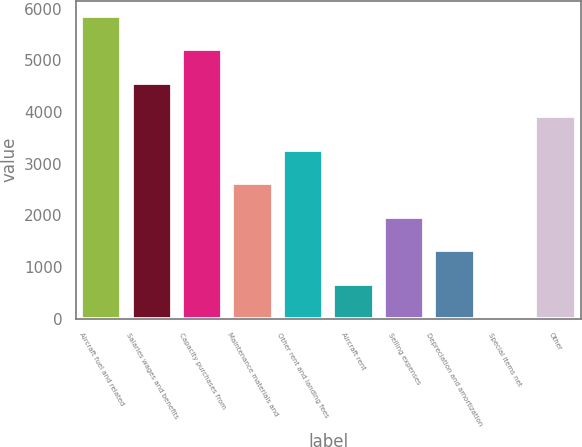Convert chart. <chart><loc_0><loc_0><loc_500><loc_500><bar_chart><fcel>Aircraft fuel and related<fcel>Salaries wages and benefits<fcel>Capacity purchases from<fcel>Maintenance materials and<fcel>Other rent and landing fees<fcel>Aircraft rent<fcel>Selling expenses<fcel>Depreciation and amortization<fcel>Special items net<fcel>Other<nl><fcel>5866.8<fcel>4568.4<fcel>5217.6<fcel>2620.8<fcel>3270<fcel>673.2<fcel>1971.6<fcel>1322.4<fcel>24<fcel>3919.2<nl></chart> 